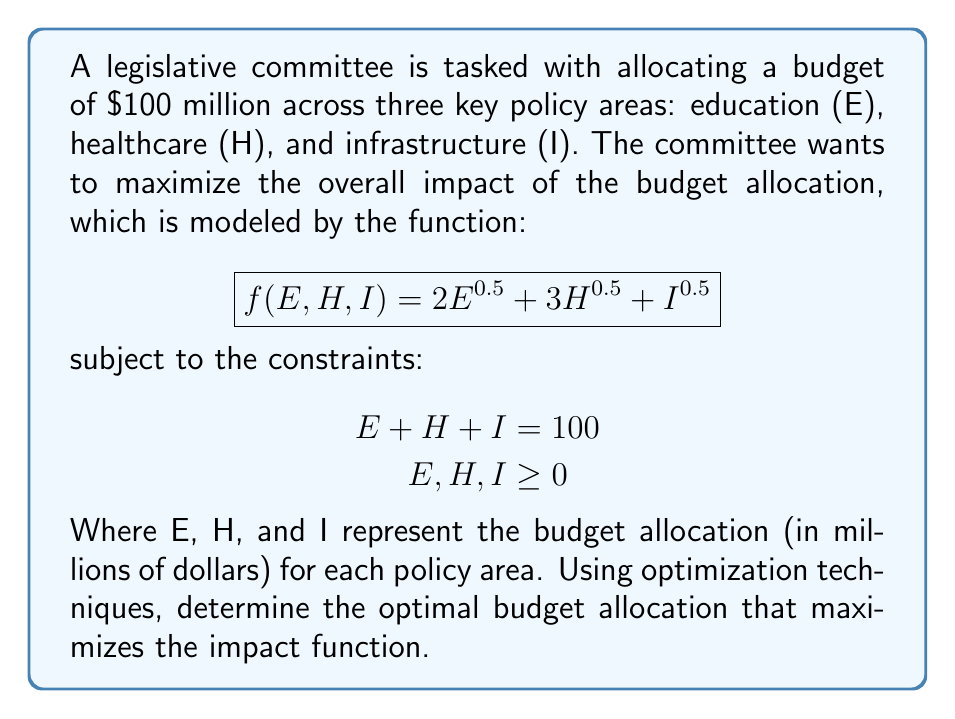Solve this math problem. To solve this optimization problem, we can use the method of Lagrange multipliers:

1. Define the Lagrangian function:
   $$L(E,H,I,\lambda) = 2E^{0.5} + 3H^{0.5} + I^{0.5} - \lambda(E + H + I - 100)$$

2. Take partial derivatives and set them equal to zero:
   $$\frac{\partial L}{\partial E} = E^{-0.5} - \lambda = 0$$
   $$\frac{\partial L}{\partial H} = \frac{3}{2}H^{-0.5} - \lambda = 0$$
   $$\frac{\partial L}{\partial I} = \frac{1}{2}I^{-0.5} - \lambda = 0$$
   $$\frac{\partial L}{\partial \lambda} = E + H + I - 100 = 0$$

3. From these equations, we can derive:
   $$E^{-0.5} = \frac{3}{2}H^{-0.5} = \frac{1}{2}I^{-0.5} = \lambda$$

4. This implies:
   $$E = \frac{4}{9}H \text{ and } I = 4H$$

5. Substituting these into the constraint equation:
   $$\frac{4}{9}H + H + 4H = 100$$
   $$\frac{49}{9}H = 100$$
   $$H = \frac{900}{49} \approx 18.37$$

6. Now we can calculate E and I:
   $$E = \frac{4}{9}H = \frac{400}{49} \approx 8.16$$
   $$I = 4H = \frac{3600}{49} \approx 73.47$$

7. Verify that the sum equals 100:
   $$8.16 + 18.37 + 73.47 = 100$$

Therefore, the optimal budget allocation is approximately:
Education (E): $8.16 million
Healthcare (H): $18.37 million
Infrastructure (I): $73.47 million
Answer: The optimal budget allocation that maximizes the impact function is:
Education: $8.16 million
Healthcare: $18.37 million
Infrastructure: $73.47 million 